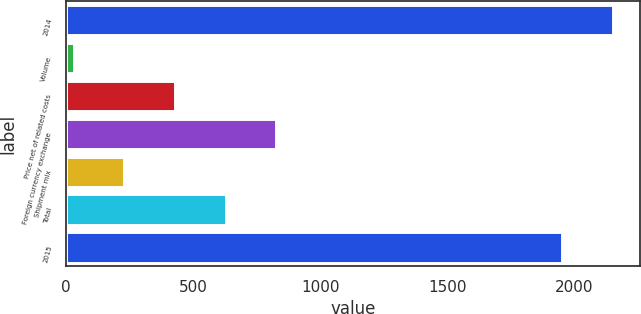<chart> <loc_0><loc_0><loc_500><loc_500><bar_chart><fcel>2014<fcel>Volume<fcel>Price net of related costs<fcel>Foreign currency exchange<fcel>Shipment mix<fcel>Total<fcel>2015<nl><fcel>2151.5<fcel>30<fcel>429<fcel>828<fcel>229.5<fcel>628.5<fcel>1952<nl></chart> 